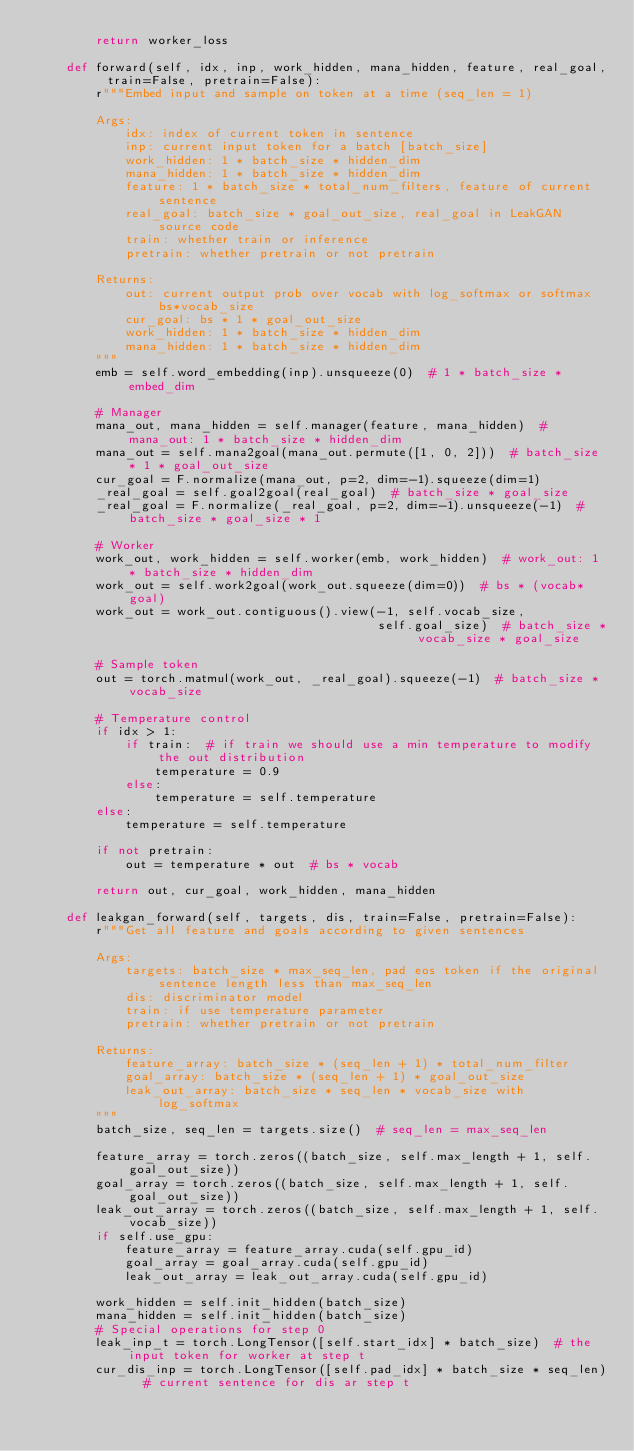Convert code to text. <code><loc_0><loc_0><loc_500><loc_500><_Python_>        return worker_loss

    def forward(self, idx, inp, work_hidden, mana_hidden, feature, real_goal, train=False, pretrain=False):
        r"""Embed input and sample on token at a time (seq_len = 1)

        Args:
            idx: index of current token in sentence
            inp: current input token for a batch [batch_size]
            work_hidden: 1 * batch_size * hidden_dim
            mana_hidden: 1 * batch_size * hidden_dim
            feature: 1 * batch_size * total_num_filters, feature of current sentence
            real_goal: batch_size * goal_out_size, real_goal in LeakGAN source code
            train: whether train or inference
            pretrain: whether pretrain or not pretrain

        Returns:
            out: current output prob over vocab with log_softmax or softmax bs*vocab_size
            cur_goal: bs * 1 * goal_out_size
            work_hidden: 1 * batch_size * hidden_dim
            mana_hidden: 1 * batch_size * hidden_dim
        """
        emb = self.word_embedding(inp).unsqueeze(0)  # 1 * batch_size * embed_dim

        # Manager
        mana_out, mana_hidden = self.manager(feature, mana_hidden)  # mana_out: 1 * batch_size * hidden_dim
        mana_out = self.mana2goal(mana_out.permute([1, 0, 2]))  # batch_size * 1 * goal_out_size
        cur_goal = F.normalize(mana_out, p=2, dim=-1).squeeze(dim=1)
        _real_goal = self.goal2goal(real_goal)  # batch_size * goal_size
        _real_goal = F.normalize(_real_goal, p=2, dim=-1).unsqueeze(-1)  # batch_size * goal_size * 1

        # Worker
        work_out, work_hidden = self.worker(emb, work_hidden)  # work_out: 1 * batch_size * hidden_dim
        work_out = self.work2goal(work_out.squeeze(dim=0))  # bs * (vocab*goal)
        work_out = work_out.contiguous().view(-1, self.vocab_size,
                                              self.goal_size)  # batch_size * vocab_size * goal_size

        # Sample token
        out = torch.matmul(work_out, _real_goal).squeeze(-1)  # batch_size * vocab_size

        # Temperature control
        if idx > 1:
            if train:  # if train we should use a min temperature to modify the out distribution
                temperature = 0.9
            else:
                temperature = self.temperature
        else:
            temperature = self.temperature

        if not pretrain:
            out = temperature * out  # bs * vocab

        return out, cur_goal, work_hidden, mana_hidden

    def leakgan_forward(self, targets, dis, train=False, pretrain=False):
        r"""Get all feature and goals according to given sentences

        Args:
            targets: batch_size * max_seq_len, pad eos token if the original sentence length less than max_seq_len
            dis: discriminator model
            train: if use temperature parameter
            pretrain: whether pretrain or not pretrain

        Returns:
            feature_array: batch_size * (seq_len + 1) * total_num_filter
            goal_array: batch_size * (seq_len + 1) * goal_out_size
            leak_out_array: batch_size * seq_len * vocab_size with log_softmax
        """
        batch_size, seq_len = targets.size()  # seq_len = max_seq_len

        feature_array = torch.zeros((batch_size, self.max_length + 1, self.goal_out_size))
        goal_array = torch.zeros((batch_size, self.max_length + 1, self.goal_out_size))
        leak_out_array = torch.zeros((batch_size, self.max_length + 1, self.vocab_size))
        if self.use_gpu:
            feature_array = feature_array.cuda(self.gpu_id)
            goal_array = goal_array.cuda(self.gpu_id)
            leak_out_array = leak_out_array.cuda(self.gpu_id)

        work_hidden = self.init_hidden(batch_size)
        mana_hidden = self.init_hidden(batch_size)
        # Special operations for step 0
        leak_inp_t = torch.LongTensor([self.start_idx] * batch_size)  # the input token for worker at step t
        cur_dis_inp = torch.LongTensor([self.pad_idx] * batch_size * seq_len)  # current sentence for dis ar step t</code> 